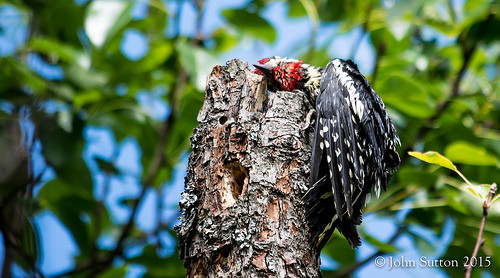<image>
Is there a leaf on the tree? Yes. Looking at the image, I can see the leaf is positioned on top of the tree, with the tree providing support. Where is the bird in relation to the tree stump? Is it on the tree stump? Yes. Looking at the image, I can see the bird is positioned on top of the tree stump, with the tree stump providing support. 